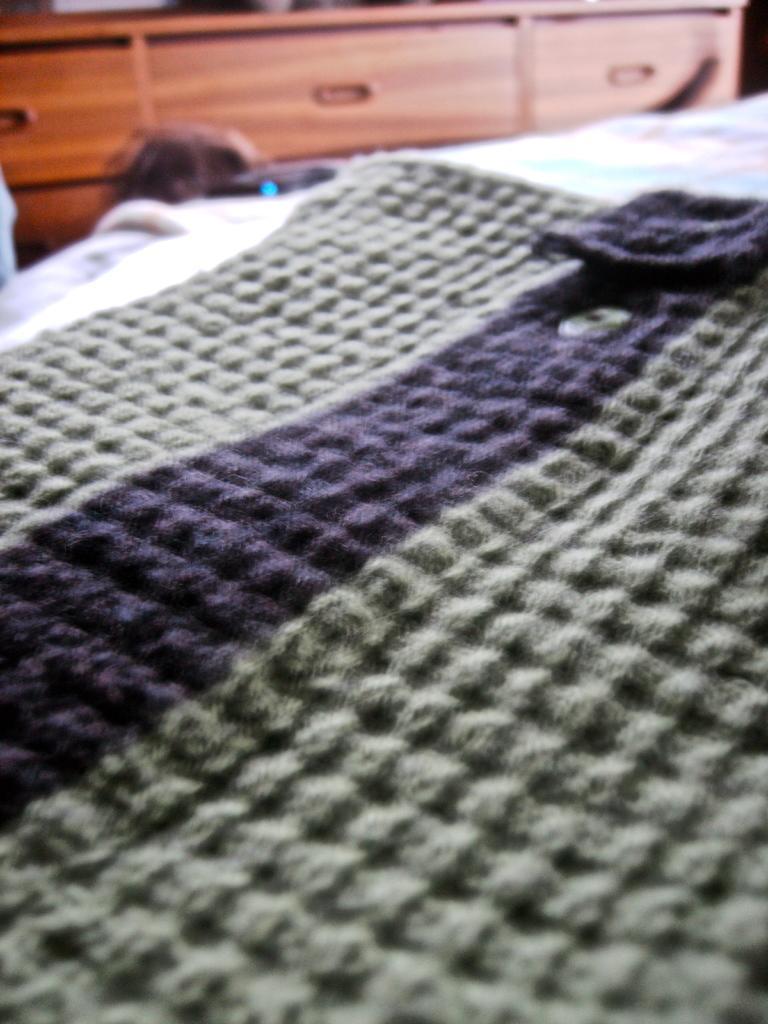How would you summarize this image in a sentence or two? In this image we can see a cloth on the bed, also we can see cupboards. 